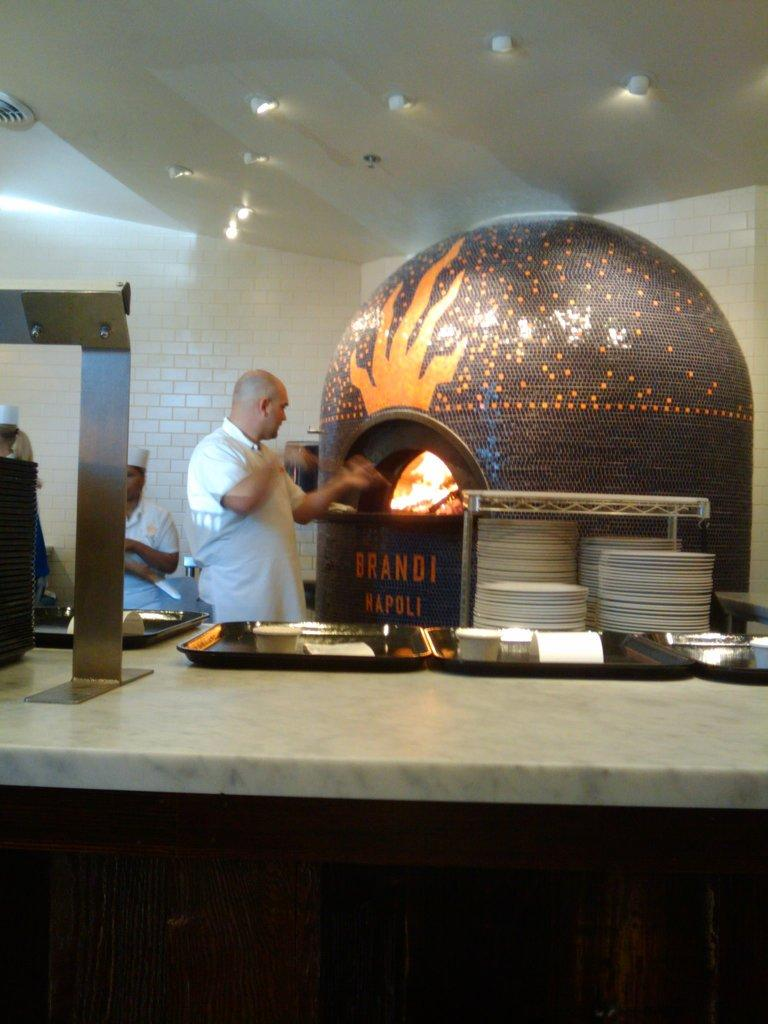<image>
Share a concise interpretation of the image provided. Under a brick oven, the words Brandi Napoli appear. 